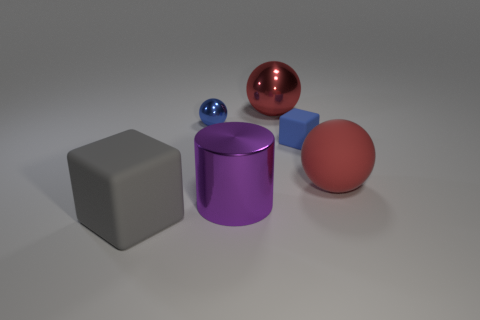The large cube is what color?
Make the answer very short. Gray. There is a large red thing in front of the tiny metallic ball; are there any blue matte cubes that are left of it?
Give a very brief answer. Yes. How many red metal things are the same size as the red matte thing?
Your answer should be very brief. 1. There is a shiny sphere to the left of the red sphere left of the red matte object; how many objects are behind it?
Provide a short and direct response. 1. What number of things are both in front of the small blue metallic ball and on the left side of the red matte ball?
Provide a short and direct response. 3. Is there anything else that has the same color as the big cylinder?
Make the answer very short. No. What number of rubber things are cylinders or tiny blue objects?
Provide a short and direct response. 1. What is the block that is behind the matte block that is in front of the large rubber object that is right of the large gray matte object made of?
Make the answer very short. Rubber. What is the large object that is behind the large red object right of the small blue block made of?
Provide a succinct answer. Metal. There is a cube that is in front of the blue block; is its size the same as the blue object that is behind the small blue block?
Your answer should be compact. No. 